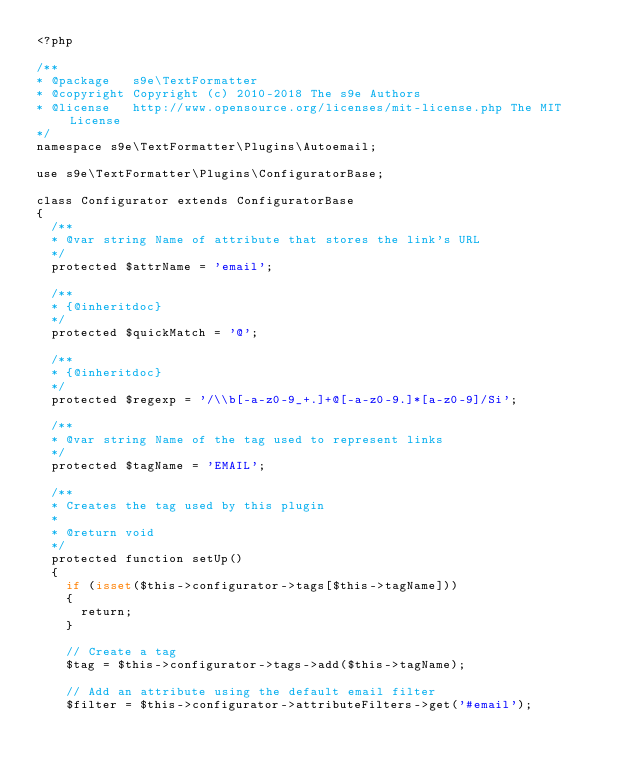Convert code to text. <code><loc_0><loc_0><loc_500><loc_500><_PHP_><?php

/**
* @package   s9e\TextFormatter
* @copyright Copyright (c) 2010-2018 The s9e Authors
* @license   http://www.opensource.org/licenses/mit-license.php The MIT License
*/
namespace s9e\TextFormatter\Plugins\Autoemail;

use s9e\TextFormatter\Plugins\ConfiguratorBase;

class Configurator extends ConfiguratorBase
{
	/**
	* @var string Name of attribute that stores the link's URL
	*/
	protected $attrName = 'email';

	/**
	* {@inheritdoc}
	*/
	protected $quickMatch = '@';

	/**
	* {@inheritdoc}
	*/
	protected $regexp = '/\\b[-a-z0-9_+.]+@[-a-z0-9.]*[a-z0-9]/Si';

	/**
	* @var string Name of the tag used to represent links
	*/
	protected $tagName = 'EMAIL';

	/**
	* Creates the tag used by this plugin
	*
	* @return void
	*/
	protected function setUp()
	{
		if (isset($this->configurator->tags[$this->tagName]))
		{
			return;
		}

		// Create a tag
		$tag = $this->configurator->tags->add($this->tagName);

		// Add an attribute using the default email filter
		$filter = $this->configurator->attributeFilters->get('#email');</code> 